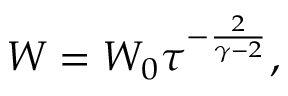Convert formula to latex. <formula><loc_0><loc_0><loc_500><loc_500>W = W _ { 0 } \tau ^ { - { \frac { 2 } { \gamma - 2 } } } ,</formula> 